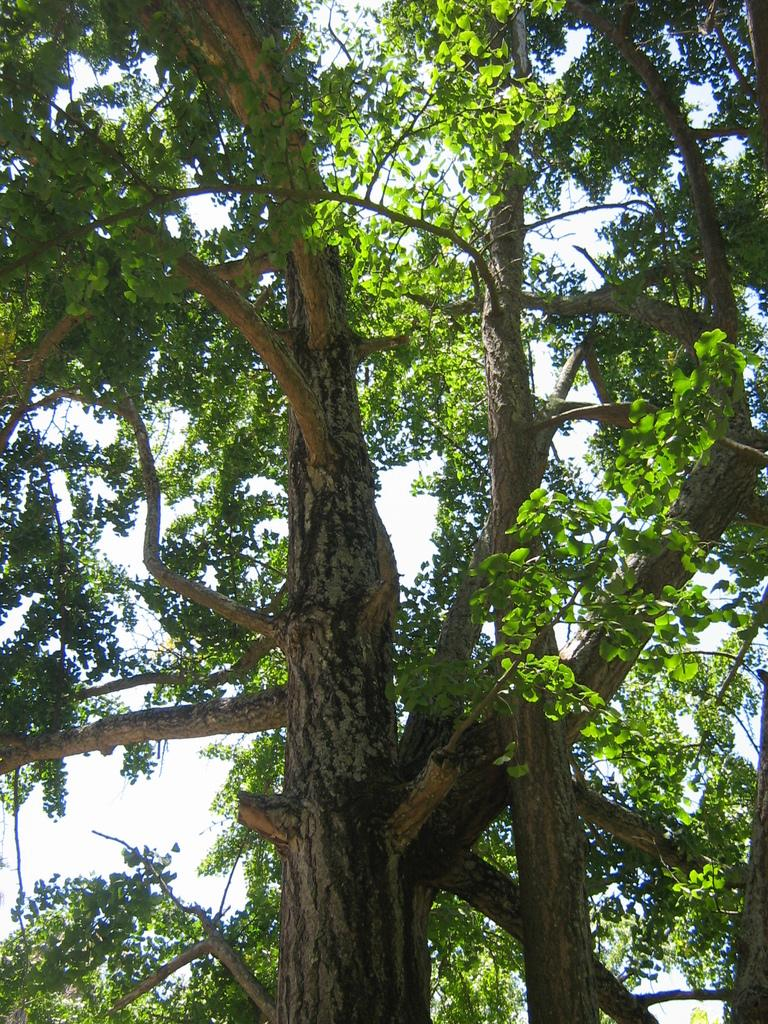What type of vegetation can be seen in the image? There are trees in the image. What is visible behind the trees in the image? The sky is visible behind the trees in the image. How many sheep can be seen grazing in the afternoon in the image? There are no sheep or indication of time of day in the image. 